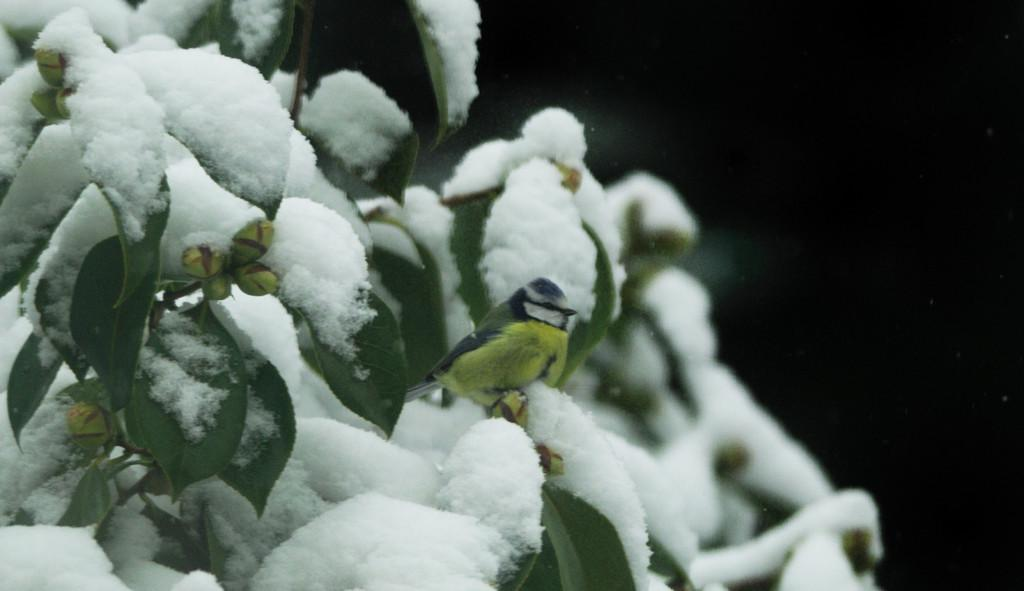What type of animal can be seen in the image? There is a bird in the image. What type of vegetation is present in the image? There are leaves in the image. What type of material is visible in the image? There is cotton in the image. What is the color of the background in the image? The background of the image is dark. What type of winter gear is the bird wearing in the image? There is no winter gear present in the image, as it features a bird, leaves, and cotton with a dark background. 